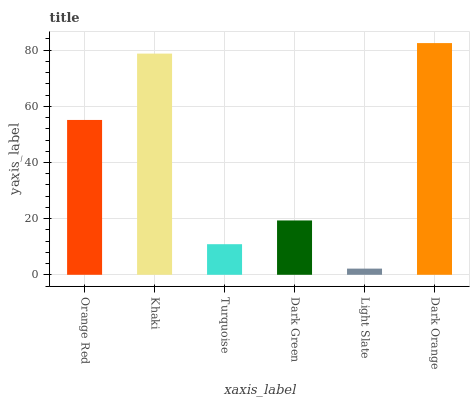Is Light Slate the minimum?
Answer yes or no. Yes. Is Dark Orange the maximum?
Answer yes or no. Yes. Is Khaki the minimum?
Answer yes or no. No. Is Khaki the maximum?
Answer yes or no. No. Is Khaki greater than Orange Red?
Answer yes or no. Yes. Is Orange Red less than Khaki?
Answer yes or no. Yes. Is Orange Red greater than Khaki?
Answer yes or no. No. Is Khaki less than Orange Red?
Answer yes or no. No. Is Orange Red the high median?
Answer yes or no. Yes. Is Dark Green the low median?
Answer yes or no. Yes. Is Light Slate the high median?
Answer yes or no. No. Is Turquoise the low median?
Answer yes or no. No. 